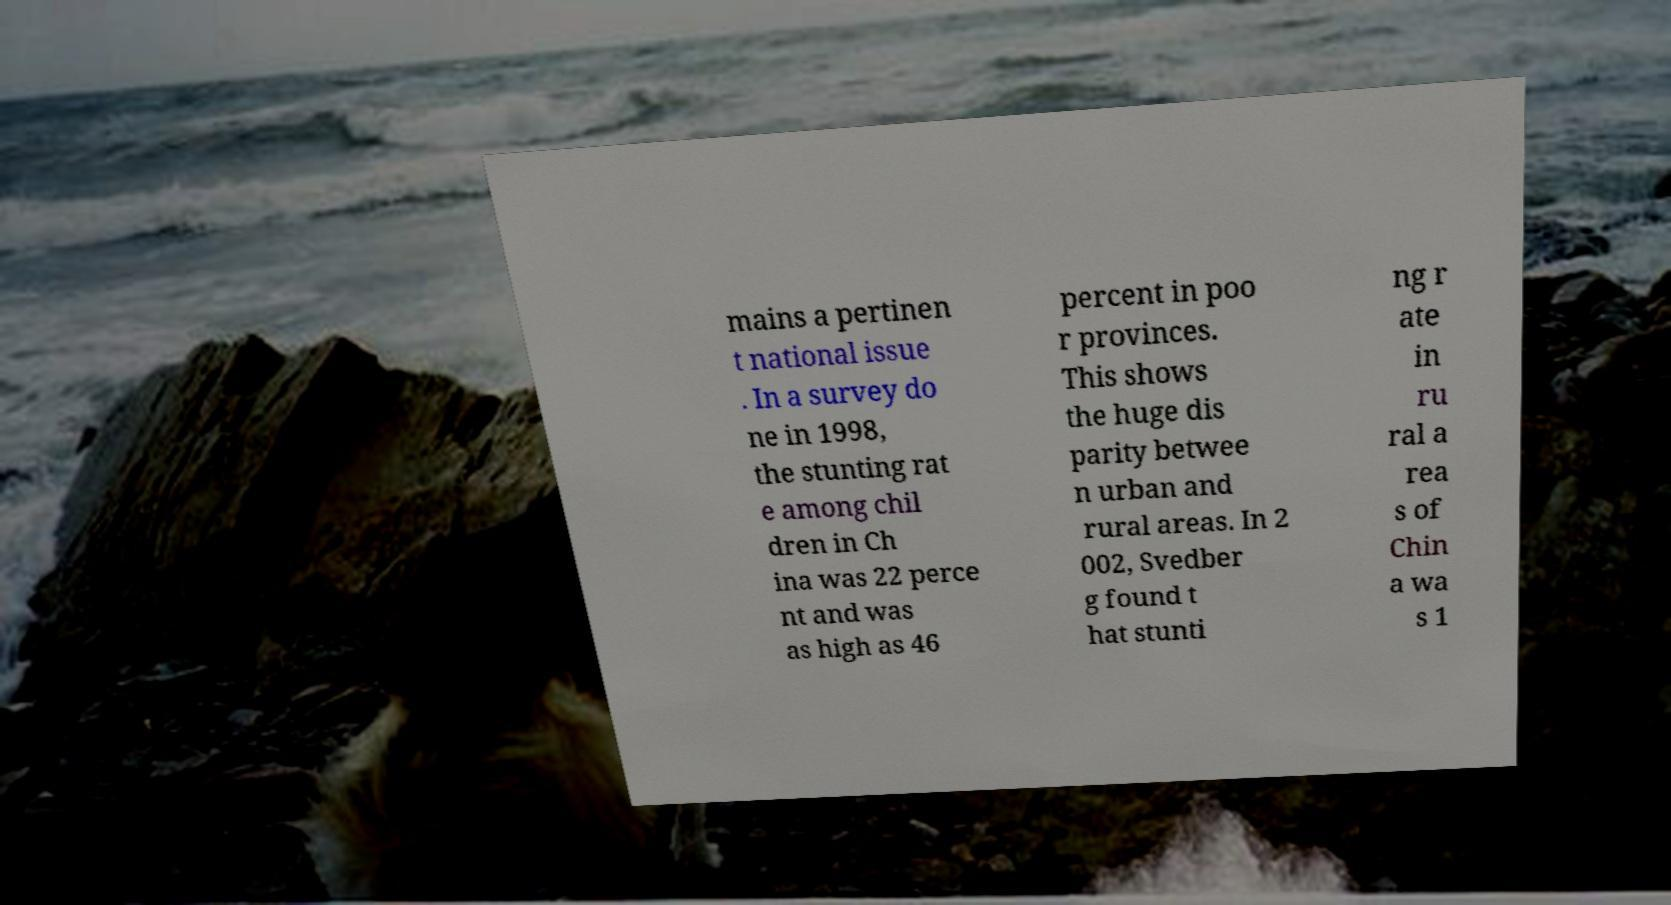There's text embedded in this image that I need extracted. Can you transcribe it verbatim? mains a pertinen t national issue . In a survey do ne in 1998, the stunting rat e among chil dren in Ch ina was 22 perce nt and was as high as 46 percent in poo r provinces. This shows the huge dis parity betwee n urban and rural areas. In 2 002, Svedber g found t hat stunti ng r ate in ru ral a rea s of Chin a wa s 1 